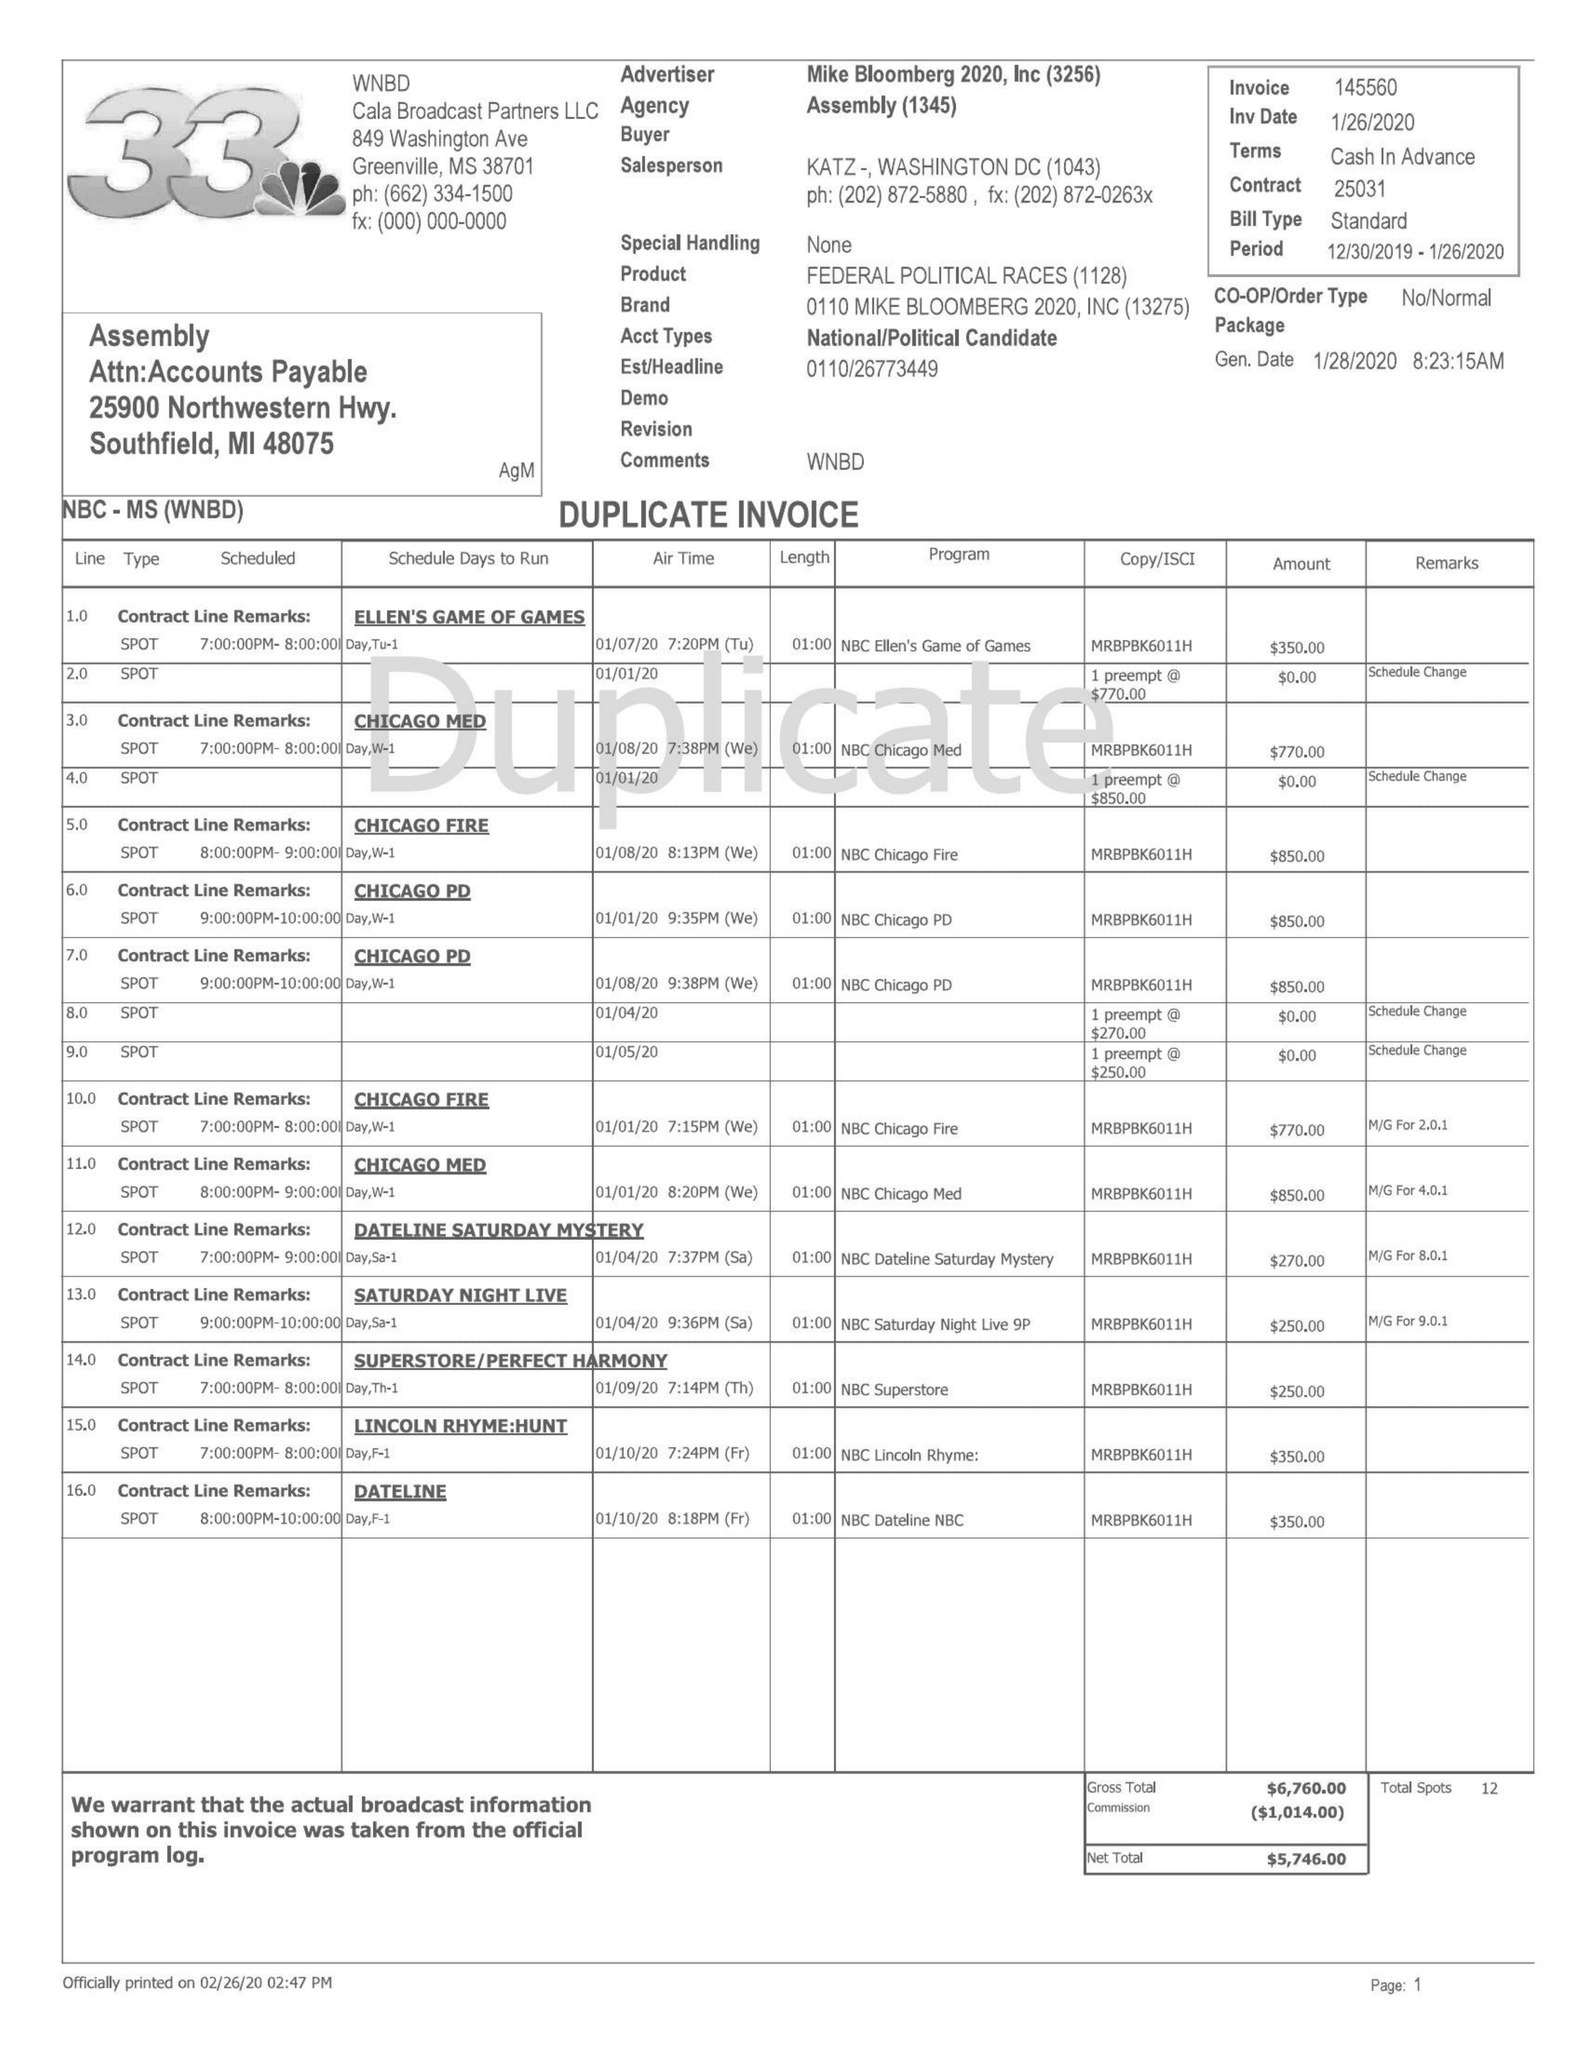What is the value for the advertiser?
Answer the question using a single word or phrase. MIKE BLOOMBERG 2020, INC 